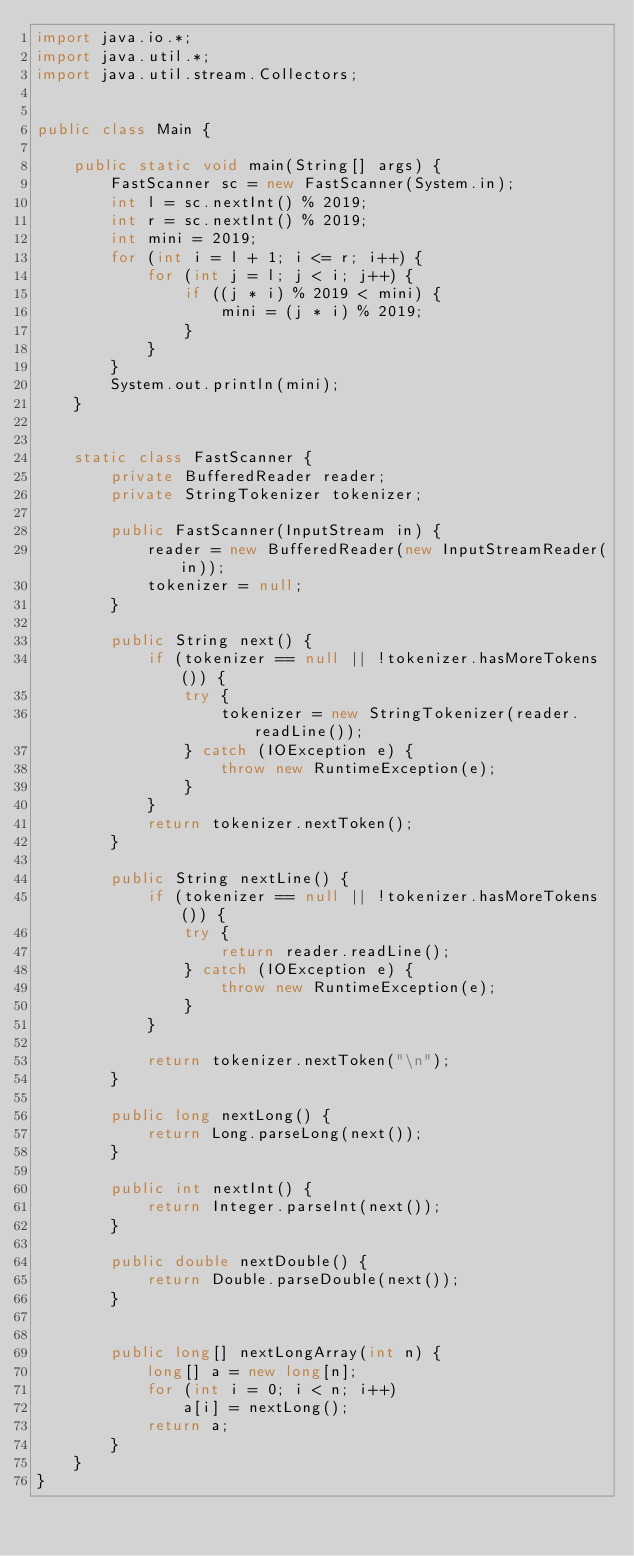Convert code to text. <code><loc_0><loc_0><loc_500><loc_500><_Java_>import java.io.*;
import java.util.*;
import java.util.stream.Collectors;


public class Main {

    public static void main(String[] args) {
        FastScanner sc = new FastScanner(System.in);
        int l = sc.nextInt() % 2019;
        int r = sc.nextInt() % 2019;
        int mini = 2019;
        for (int i = l + 1; i <= r; i++) {
            for (int j = l; j < i; j++) {
                if ((j * i) % 2019 < mini) {
                    mini = (j * i) % 2019;
                }
            }
        }
        System.out.println(mini);
    }


    static class FastScanner {
        private BufferedReader reader;
        private StringTokenizer tokenizer;

        public FastScanner(InputStream in) {
            reader = new BufferedReader(new InputStreamReader(in));
            tokenizer = null;
        }

        public String next() {
            if (tokenizer == null || !tokenizer.hasMoreTokens()) {
                try {
                    tokenizer = new StringTokenizer(reader.readLine());
                } catch (IOException e) {
                    throw new RuntimeException(e);
                }
            }
            return tokenizer.nextToken();
        }

        public String nextLine() {
            if (tokenizer == null || !tokenizer.hasMoreTokens()) {
                try {
                    return reader.readLine();
                } catch (IOException e) {
                    throw new RuntimeException(e);
                }
            }

            return tokenizer.nextToken("\n");
        }

        public long nextLong() {
            return Long.parseLong(next());
        }

        public int nextInt() {
            return Integer.parseInt(next());
        }

        public double nextDouble() {
            return Double.parseDouble(next());
        }


        public long[] nextLongArray(int n) {
            long[] a = new long[n];
            for (int i = 0; i < n; i++)
                a[i] = nextLong();
            return a;
        }
    }
}
</code> 